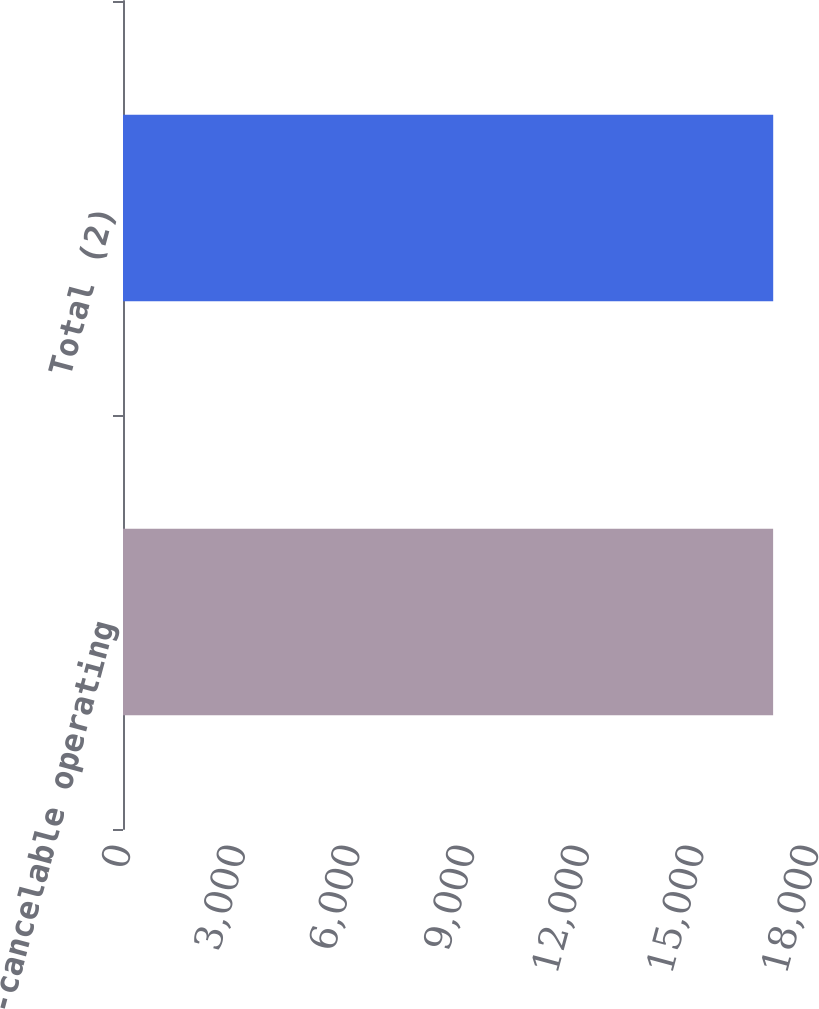<chart> <loc_0><loc_0><loc_500><loc_500><bar_chart><fcel>Non-cancelable operating<fcel>Total (2)<nl><fcel>17009<fcel>17011<nl></chart> 